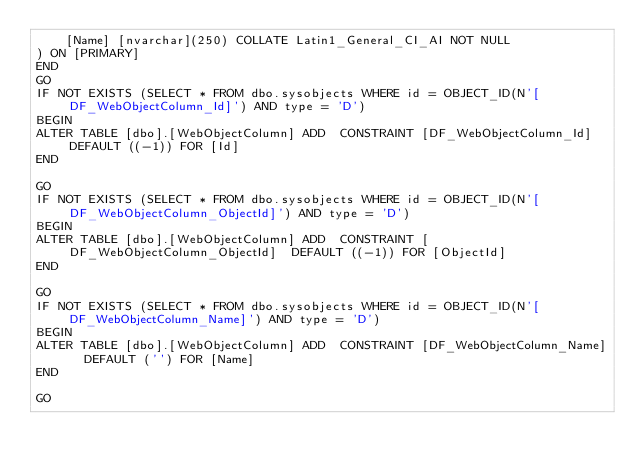Convert code to text. <code><loc_0><loc_0><loc_500><loc_500><_SQL_>	[Name] [nvarchar](250) COLLATE Latin1_General_CI_AI NOT NULL
) ON [PRIMARY]
END
GO
IF NOT EXISTS (SELECT * FROM dbo.sysobjects WHERE id = OBJECT_ID(N'[DF_WebObjectColumn_Id]') AND type = 'D')
BEGIN
ALTER TABLE [dbo].[WebObjectColumn] ADD  CONSTRAINT [DF_WebObjectColumn_Id]  DEFAULT ((-1)) FOR [Id]
END

GO
IF NOT EXISTS (SELECT * FROM dbo.sysobjects WHERE id = OBJECT_ID(N'[DF_WebObjectColumn_ObjectId]') AND type = 'D')
BEGIN
ALTER TABLE [dbo].[WebObjectColumn] ADD  CONSTRAINT [DF_WebObjectColumn_ObjectId]  DEFAULT ((-1)) FOR [ObjectId]
END

GO
IF NOT EXISTS (SELECT * FROM dbo.sysobjects WHERE id = OBJECT_ID(N'[DF_WebObjectColumn_Name]') AND type = 'D')
BEGIN
ALTER TABLE [dbo].[WebObjectColumn] ADD  CONSTRAINT [DF_WebObjectColumn_Name]  DEFAULT ('') FOR [Name]
END

GO
</code> 